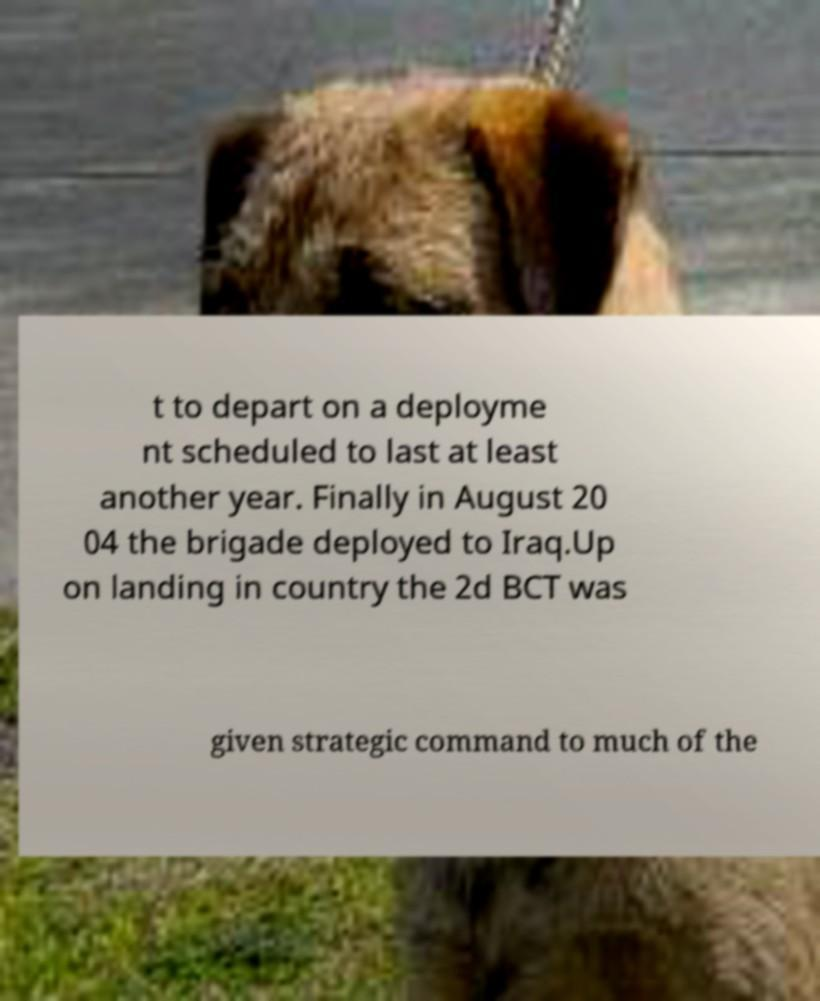Could you extract and type out the text from this image? t to depart on a deployme nt scheduled to last at least another year. Finally in August 20 04 the brigade deployed to Iraq.Up on landing in country the 2d BCT was given strategic command to much of the 